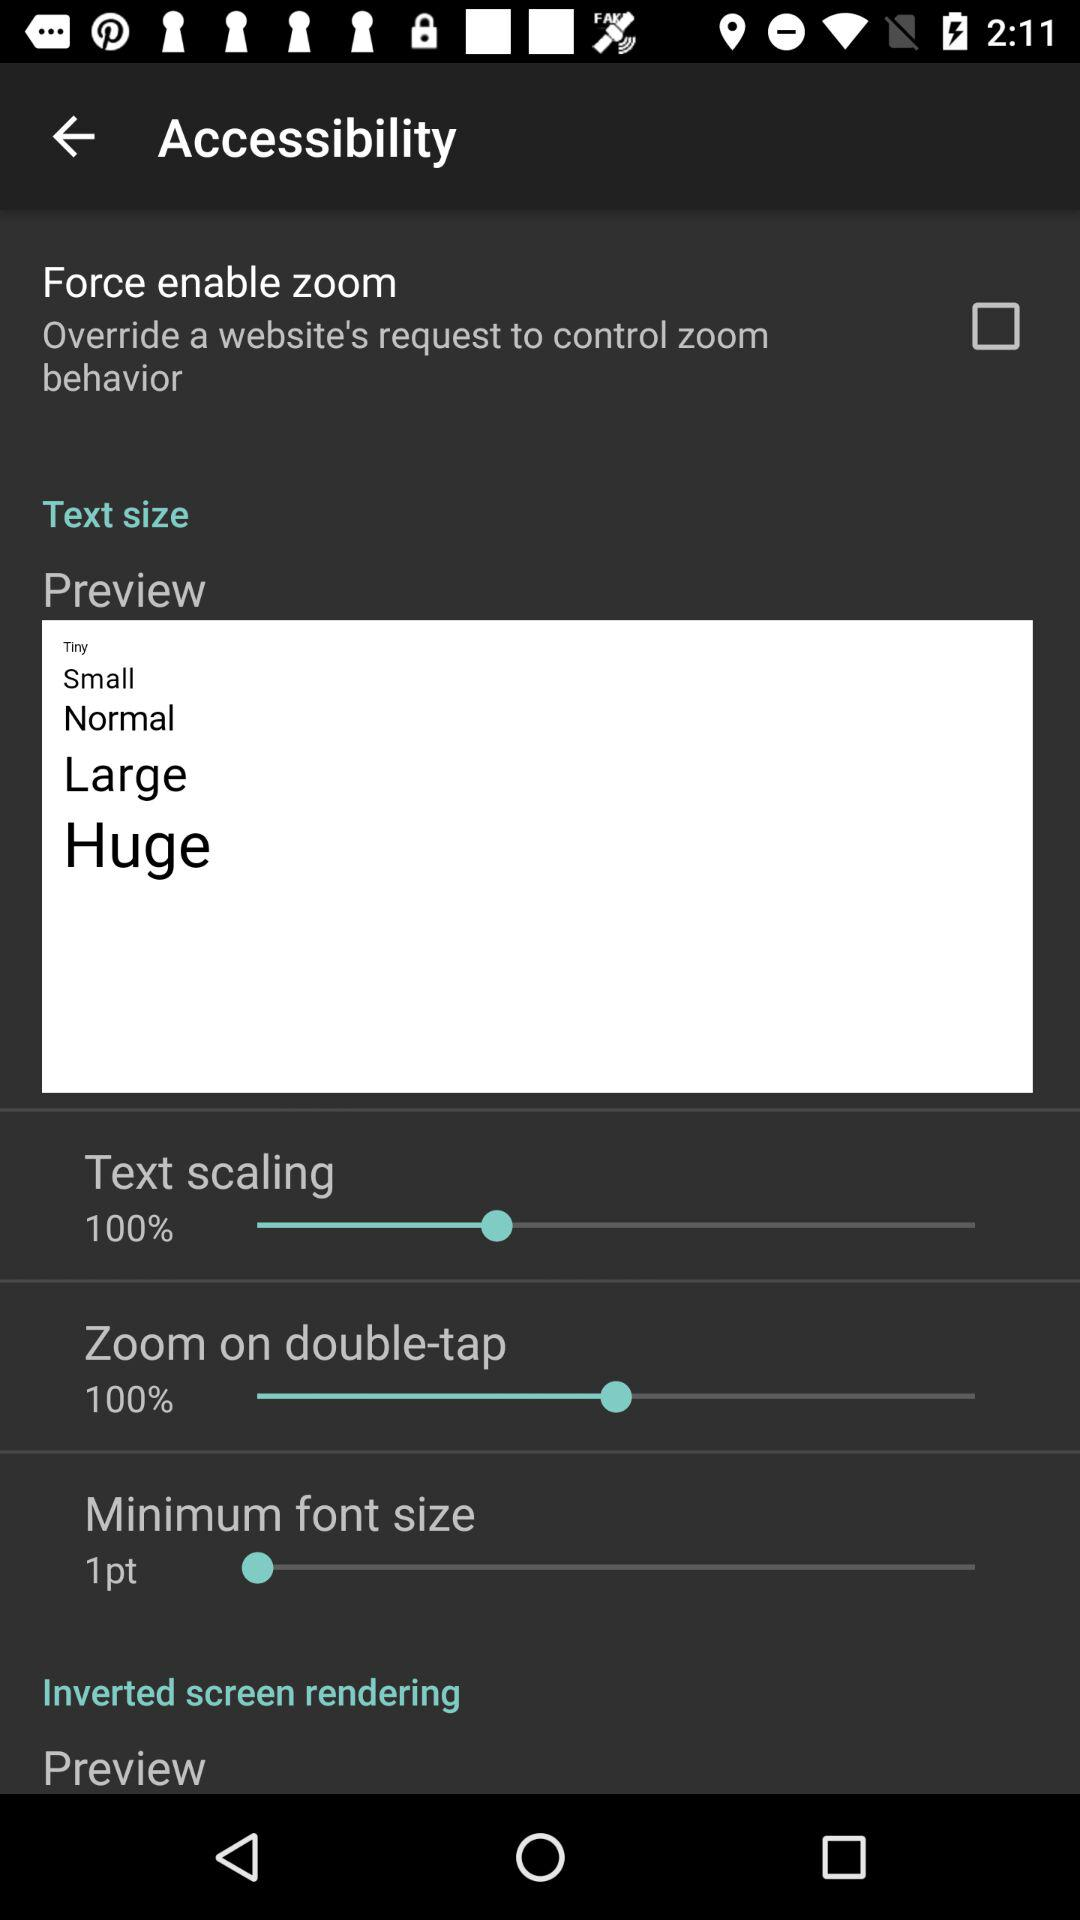How many items are there under Text size?
Answer the question using a single word or phrase. 4 